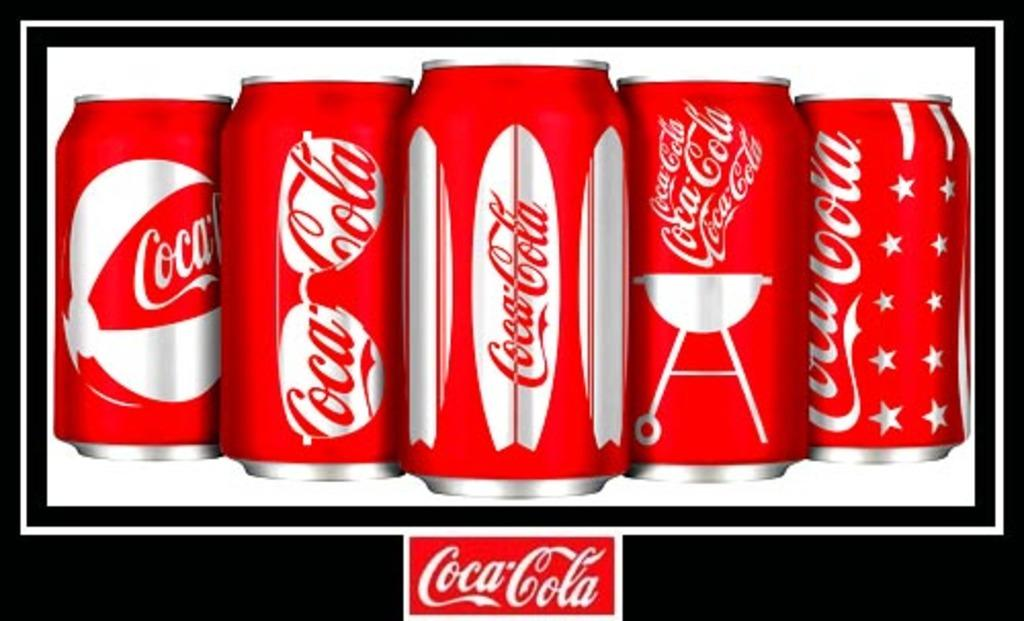What type of beverages are in the bottles visible in the image? There are cool drink bottles in the image. What additional detail can be observed about the cool drink bottles? The cool drink bottles have text written on them. What type of belief is represented by the eggnog in the image? There is no eggnog present in the image, and therefore no such belief can be observed. What type of battle is depicted in the image? There is no battle depicted in the image; it features cool drink bottles with text written on them. 